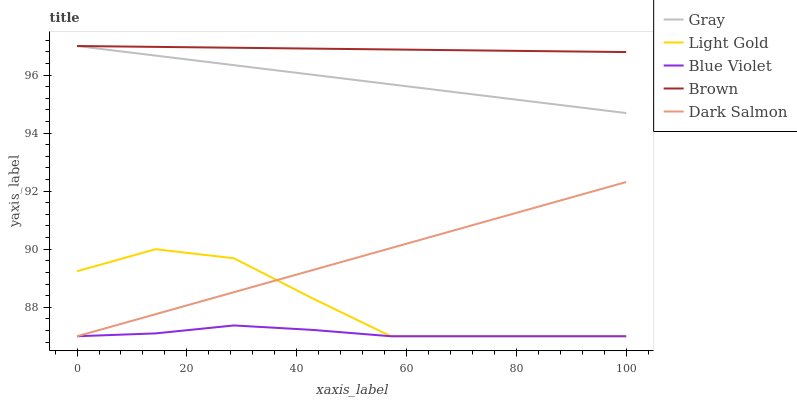Does Blue Violet have the minimum area under the curve?
Answer yes or no. Yes. Does Brown have the maximum area under the curve?
Answer yes or no. Yes. Does Light Gold have the minimum area under the curve?
Answer yes or no. No. Does Light Gold have the maximum area under the curve?
Answer yes or no. No. Is Brown the smoothest?
Answer yes or no. Yes. Is Light Gold the roughest?
Answer yes or no. Yes. Is Dark Salmon the smoothest?
Answer yes or no. No. Is Dark Salmon the roughest?
Answer yes or no. No. Does Brown have the lowest value?
Answer yes or no. No. Does Brown have the highest value?
Answer yes or no. Yes. Does Light Gold have the highest value?
Answer yes or no. No. Is Light Gold less than Brown?
Answer yes or no. Yes. Is Gray greater than Blue Violet?
Answer yes or no. Yes. Does Blue Violet intersect Dark Salmon?
Answer yes or no. Yes. Is Blue Violet less than Dark Salmon?
Answer yes or no. No. Is Blue Violet greater than Dark Salmon?
Answer yes or no. No. Does Light Gold intersect Brown?
Answer yes or no. No. 